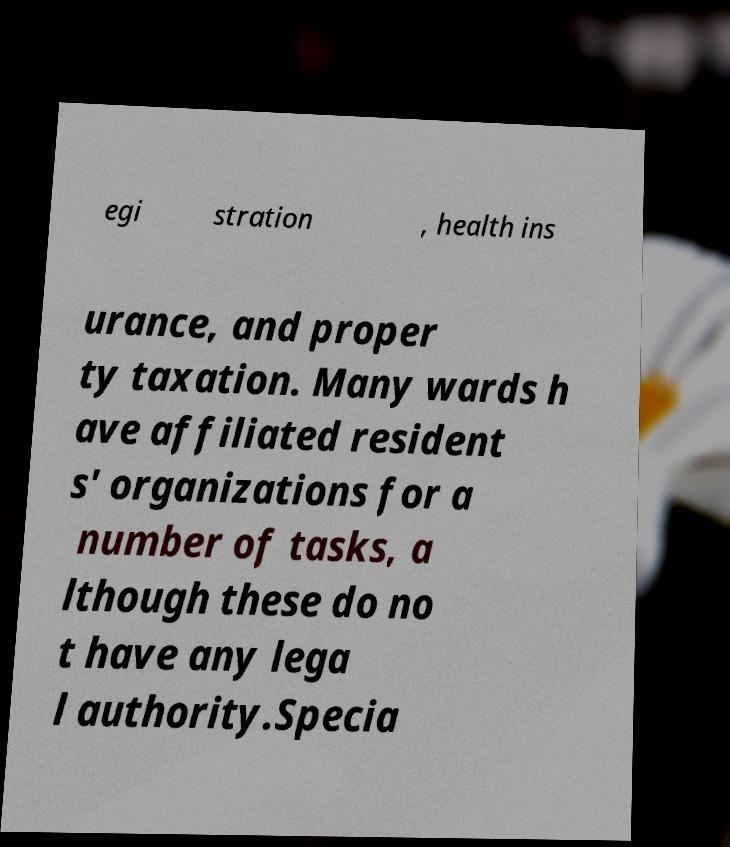Can you accurately transcribe the text from the provided image for me? egi stration , health ins urance, and proper ty taxation. Many wards h ave affiliated resident s' organizations for a number of tasks, a lthough these do no t have any lega l authority.Specia 